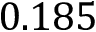Convert formula to latex. <formula><loc_0><loc_0><loc_500><loc_500>0 . 1 8 5</formula> 